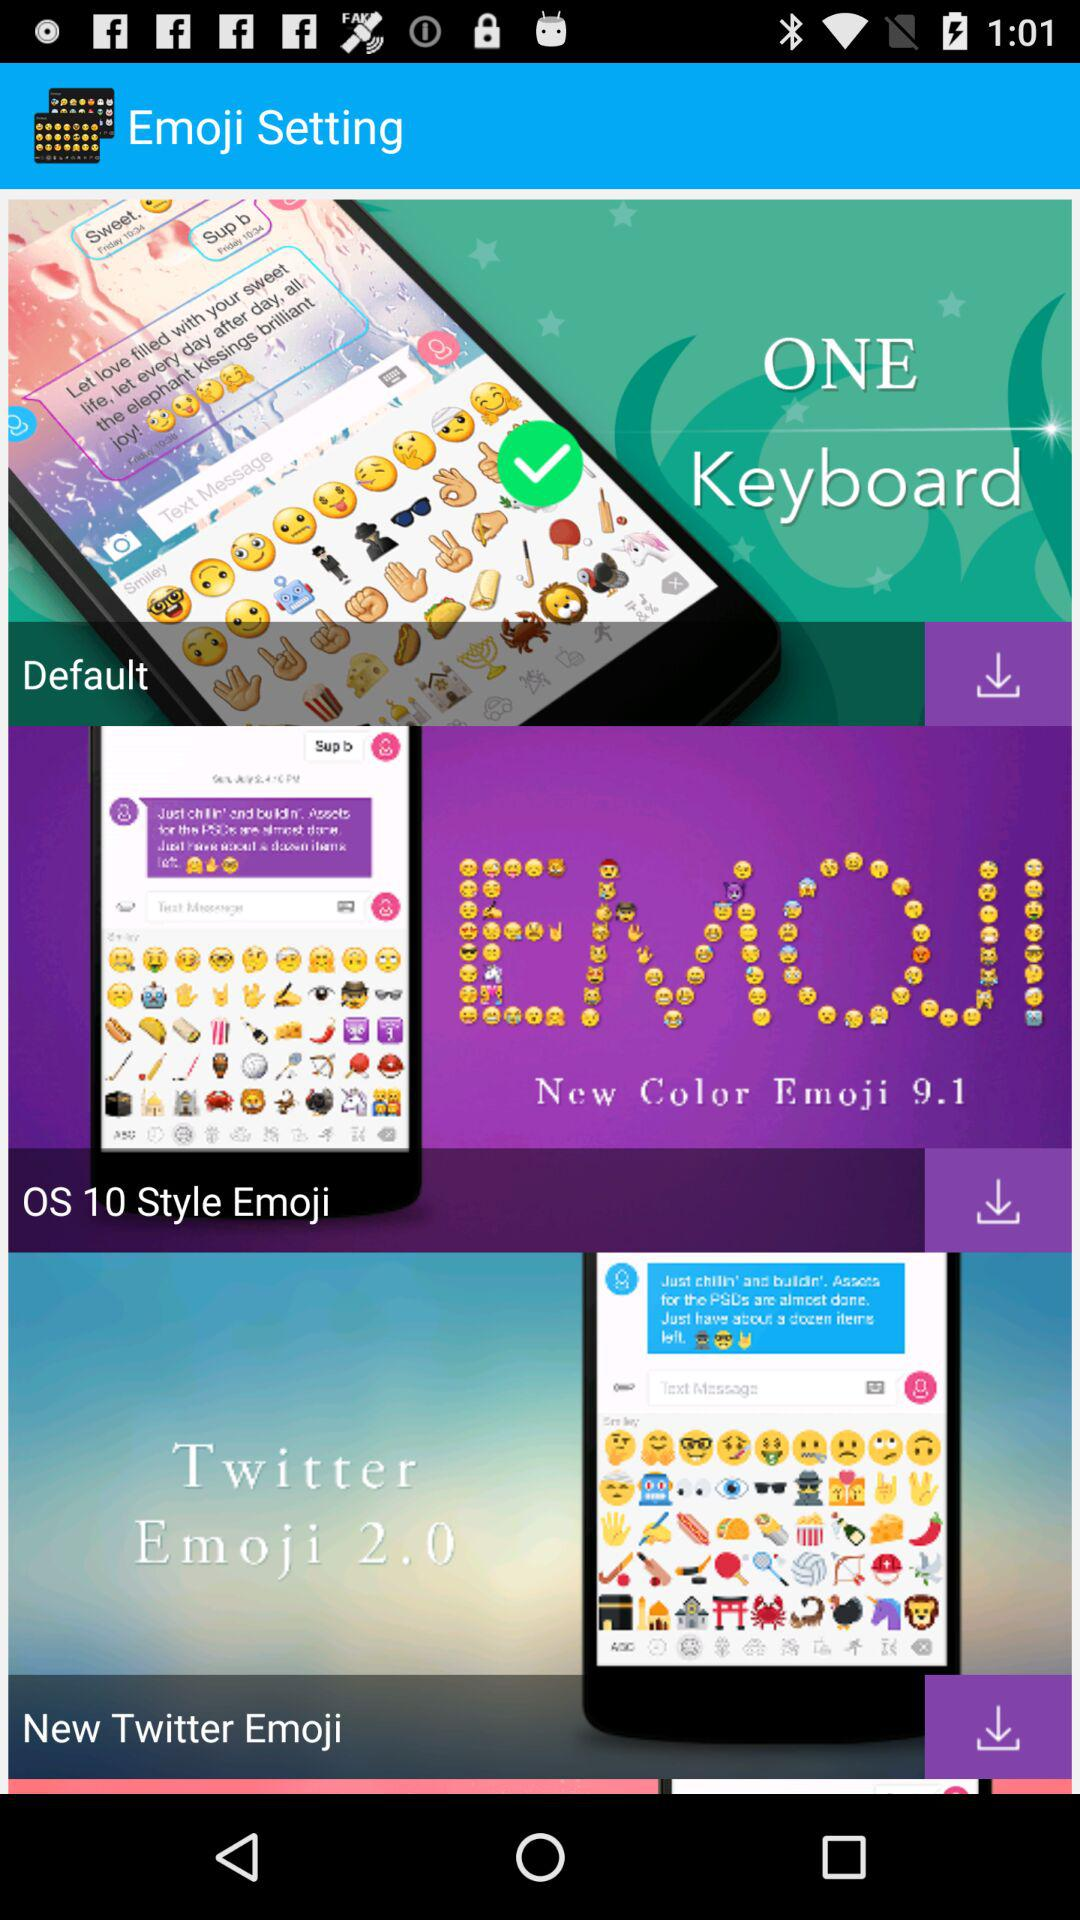How many emoji keyboard options are there?
Answer the question using a single word or phrase. 3 